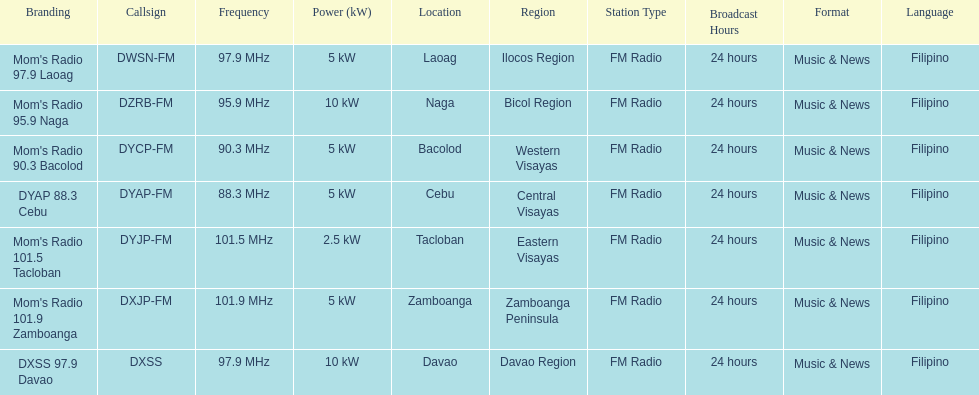Which of these stations transmits with the lowest power? Mom's Radio 101.5 Tacloban. 